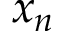Convert formula to latex. <formula><loc_0><loc_0><loc_500><loc_500>x _ { n }</formula> 